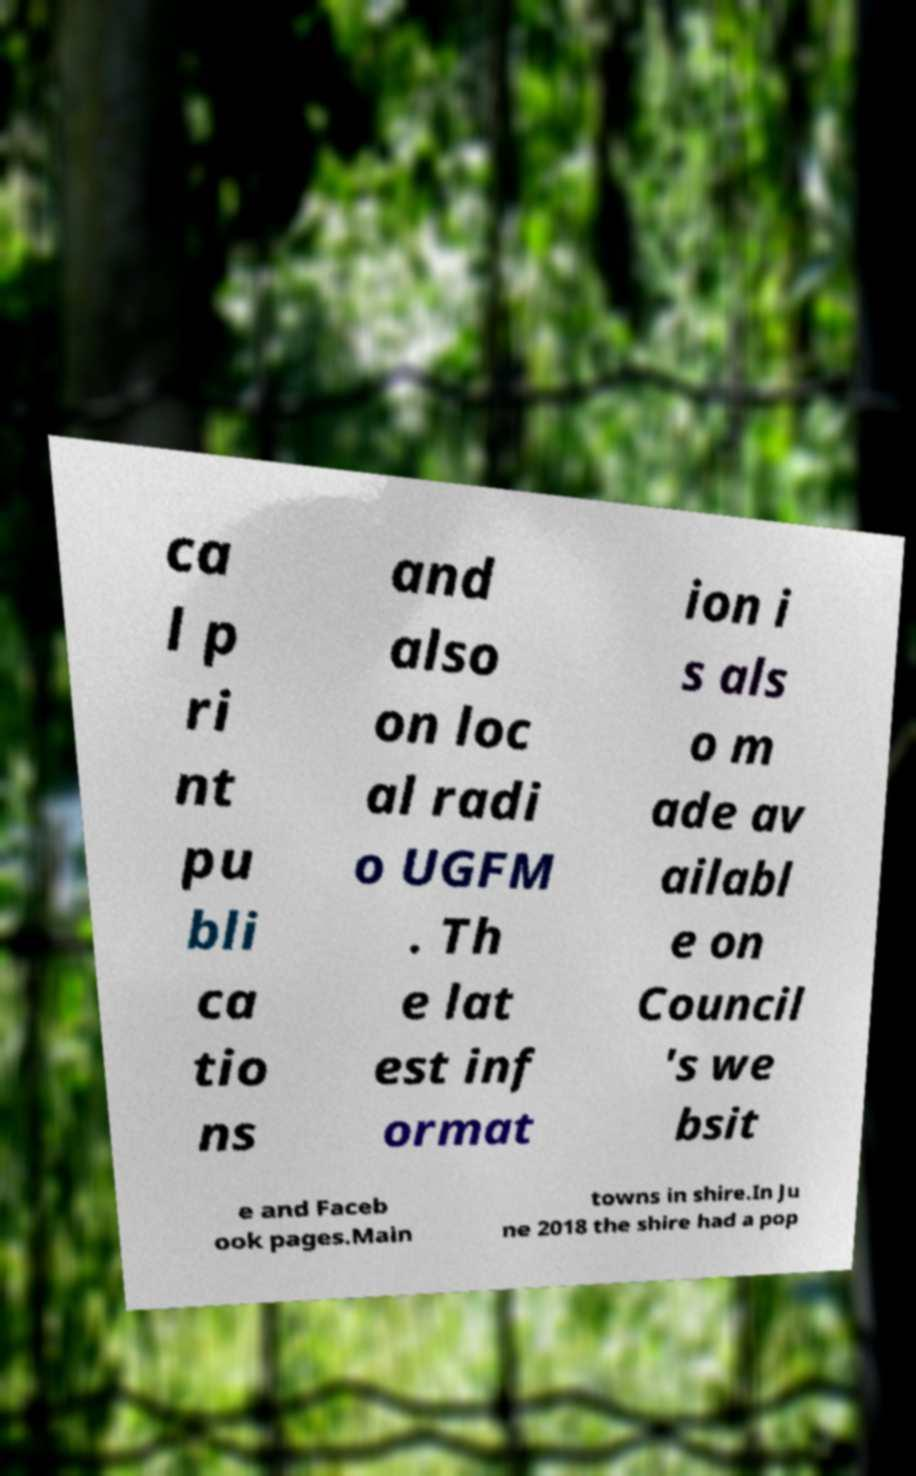Can you accurately transcribe the text from the provided image for me? ca l p ri nt pu bli ca tio ns and also on loc al radi o UGFM . Th e lat est inf ormat ion i s als o m ade av ailabl e on Council 's we bsit e and Faceb ook pages.Main towns in shire.In Ju ne 2018 the shire had a pop 